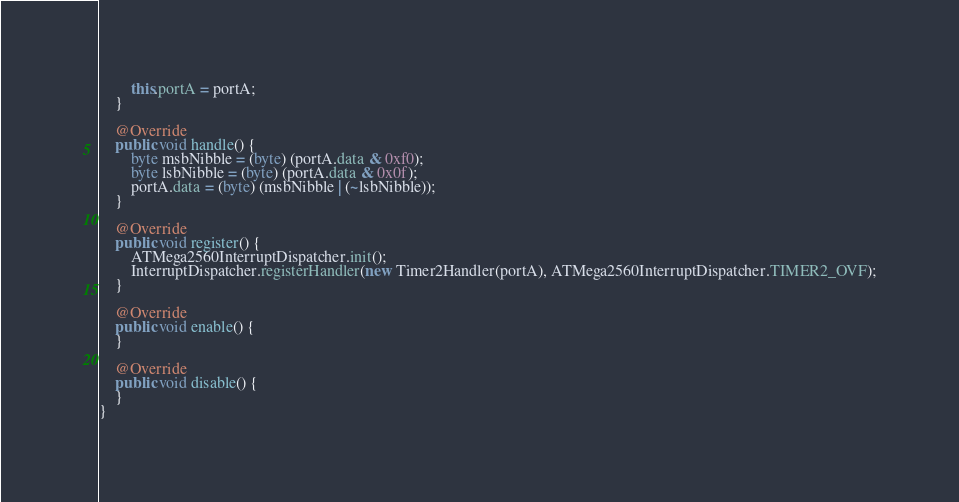<code> <loc_0><loc_0><loc_500><loc_500><_Java_>        this.portA = portA;
    }

    @Override
    public void handle() {
        byte msbNibble = (byte) (portA.data & 0xf0);
        byte lsbNibble = (byte) (portA.data & 0x0f);
        portA.data = (byte) (msbNibble | (~lsbNibble)); 
    }

	@Override
	public void register() {
        ATMega2560InterruptDispatcher.init();
        InterruptDispatcher.registerHandler(new Timer2Handler(portA), ATMega2560InterruptDispatcher.TIMER2_OVF);
	}

	@Override
	public void enable() {
	}

	@Override
	public void disable() {
	}
}
</code> 